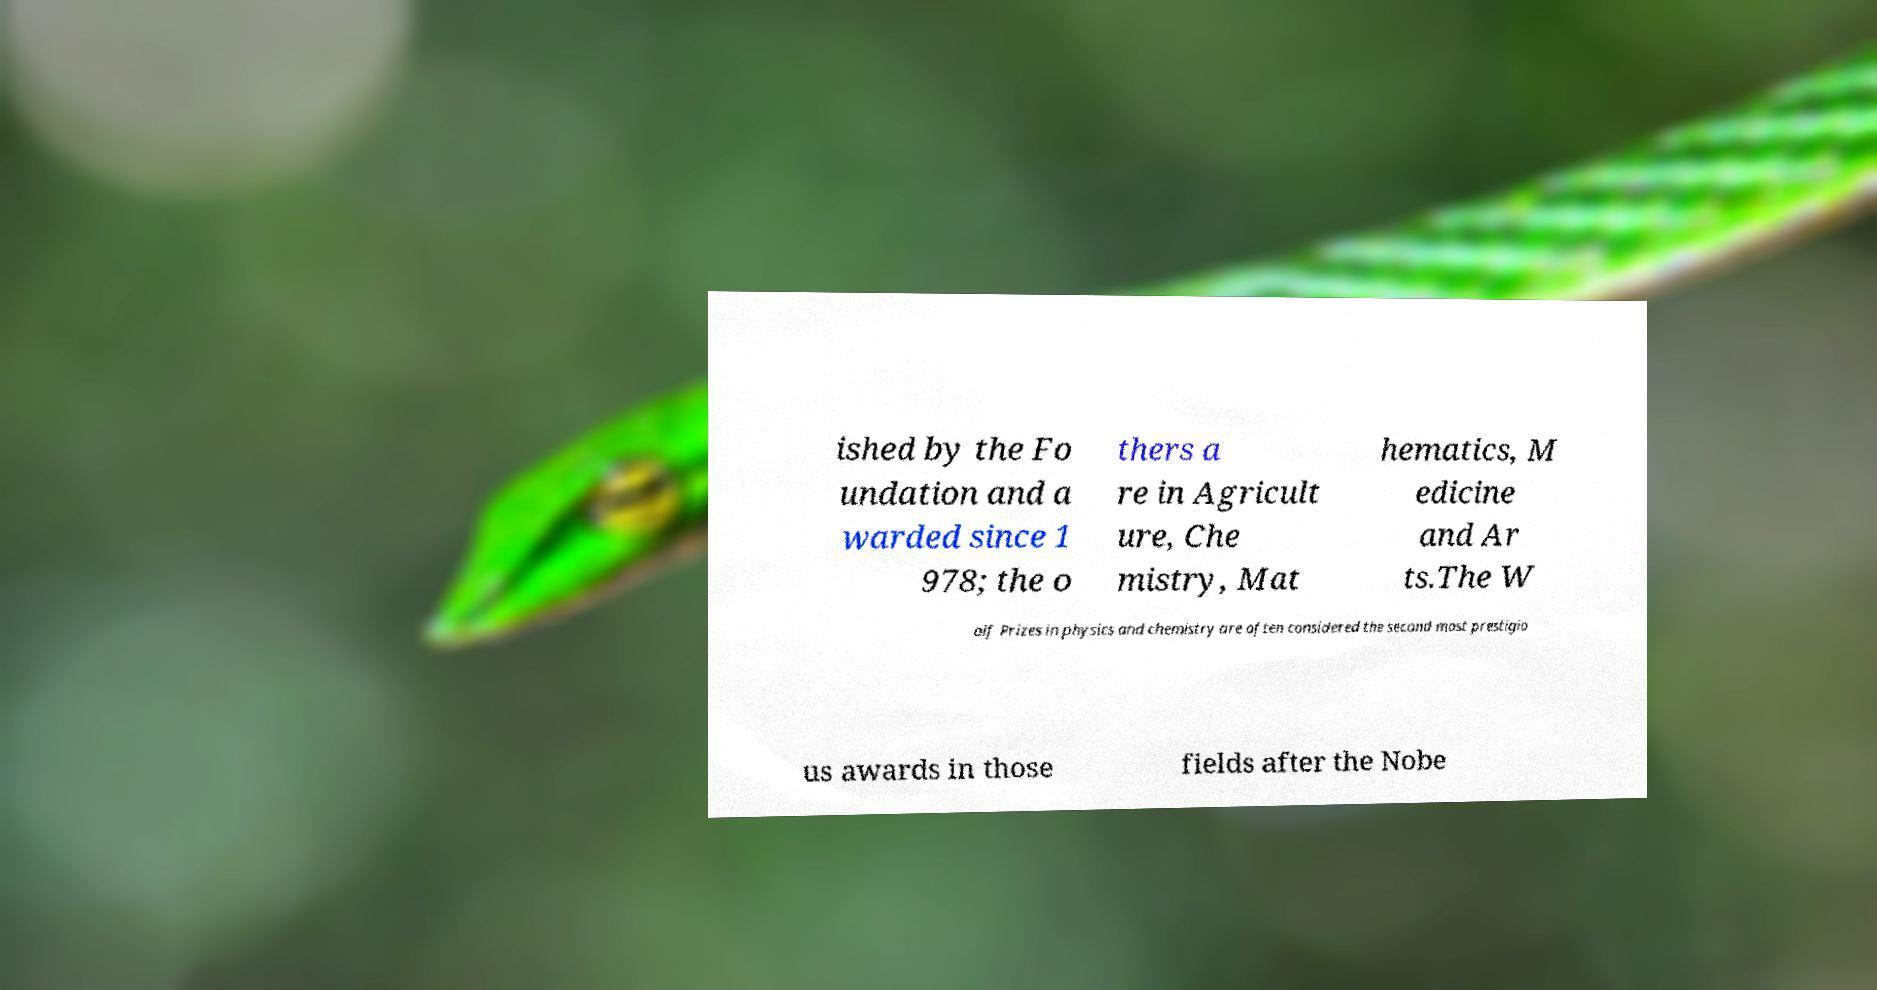Can you read and provide the text displayed in the image?This photo seems to have some interesting text. Can you extract and type it out for me? ished by the Fo undation and a warded since 1 978; the o thers a re in Agricult ure, Che mistry, Mat hematics, M edicine and Ar ts.The W olf Prizes in physics and chemistry are often considered the second most prestigio us awards in those fields after the Nobe 